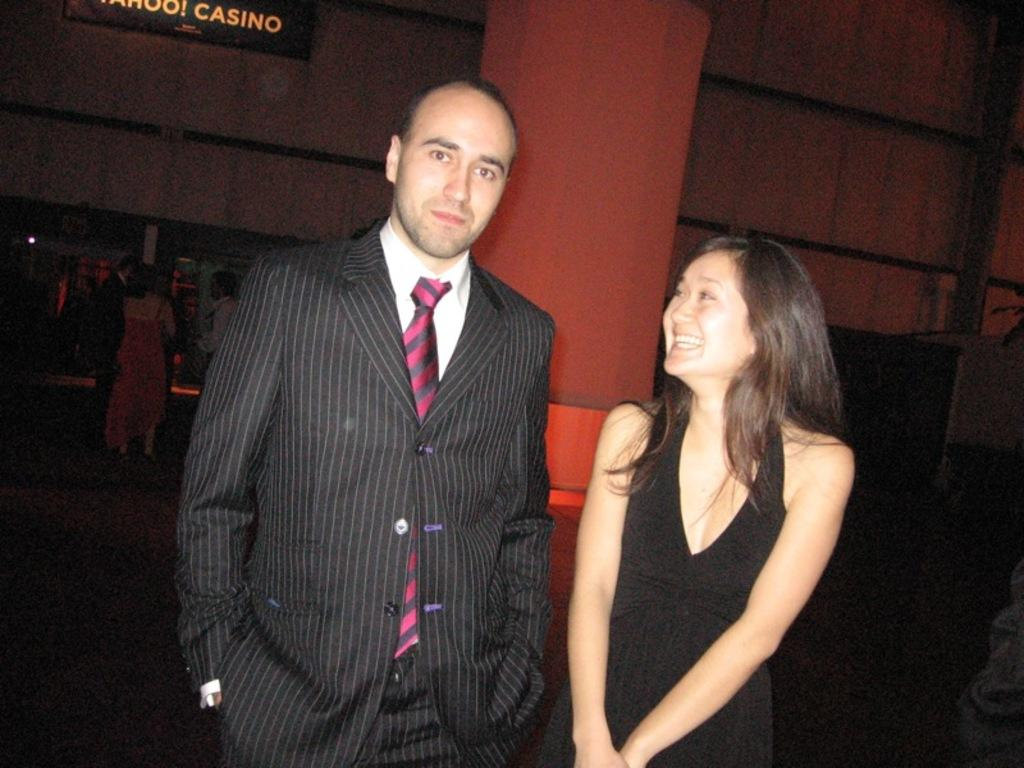How many people can be seen in the image? There are five people visible in the image. What are the people doing in the image? The people are standing or sitting in front of a beam and on the floor on the left side. What is the background of the image? There is a wall visible at the back. What song is being sung by the people in the image? There is no indication in the image that the people are singing a song, so it cannot be determined from the picture. 